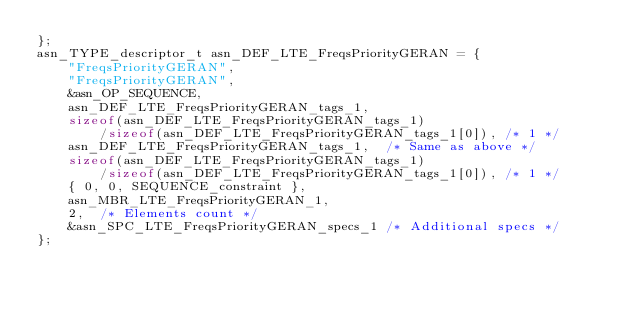Convert code to text. <code><loc_0><loc_0><loc_500><loc_500><_C_>};
asn_TYPE_descriptor_t asn_DEF_LTE_FreqsPriorityGERAN = {
	"FreqsPriorityGERAN",
	"FreqsPriorityGERAN",
	&asn_OP_SEQUENCE,
	asn_DEF_LTE_FreqsPriorityGERAN_tags_1,
	sizeof(asn_DEF_LTE_FreqsPriorityGERAN_tags_1)
		/sizeof(asn_DEF_LTE_FreqsPriorityGERAN_tags_1[0]), /* 1 */
	asn_DEF_LTE_FreqsPriorityGERAN_tags_1,	/* Same as above */
	sizeof(asn_DEF_LTE_FreqsPriorityGERAN_tags_1)
		/sizeof(asn_DEF_LTE_FreqsPriorityGERAN_tags_1[0]), /* 1 */
	{ 0, 0, SEQUENCE_constraint },
	asn_MBR_LTE_FreqsPriorityGERAN_1,
	2,	/* Elements count */
	&asn_SPC_LTE_FreqsPriorityGERAN_specs_1	/* Additional specs */
};

</code> 